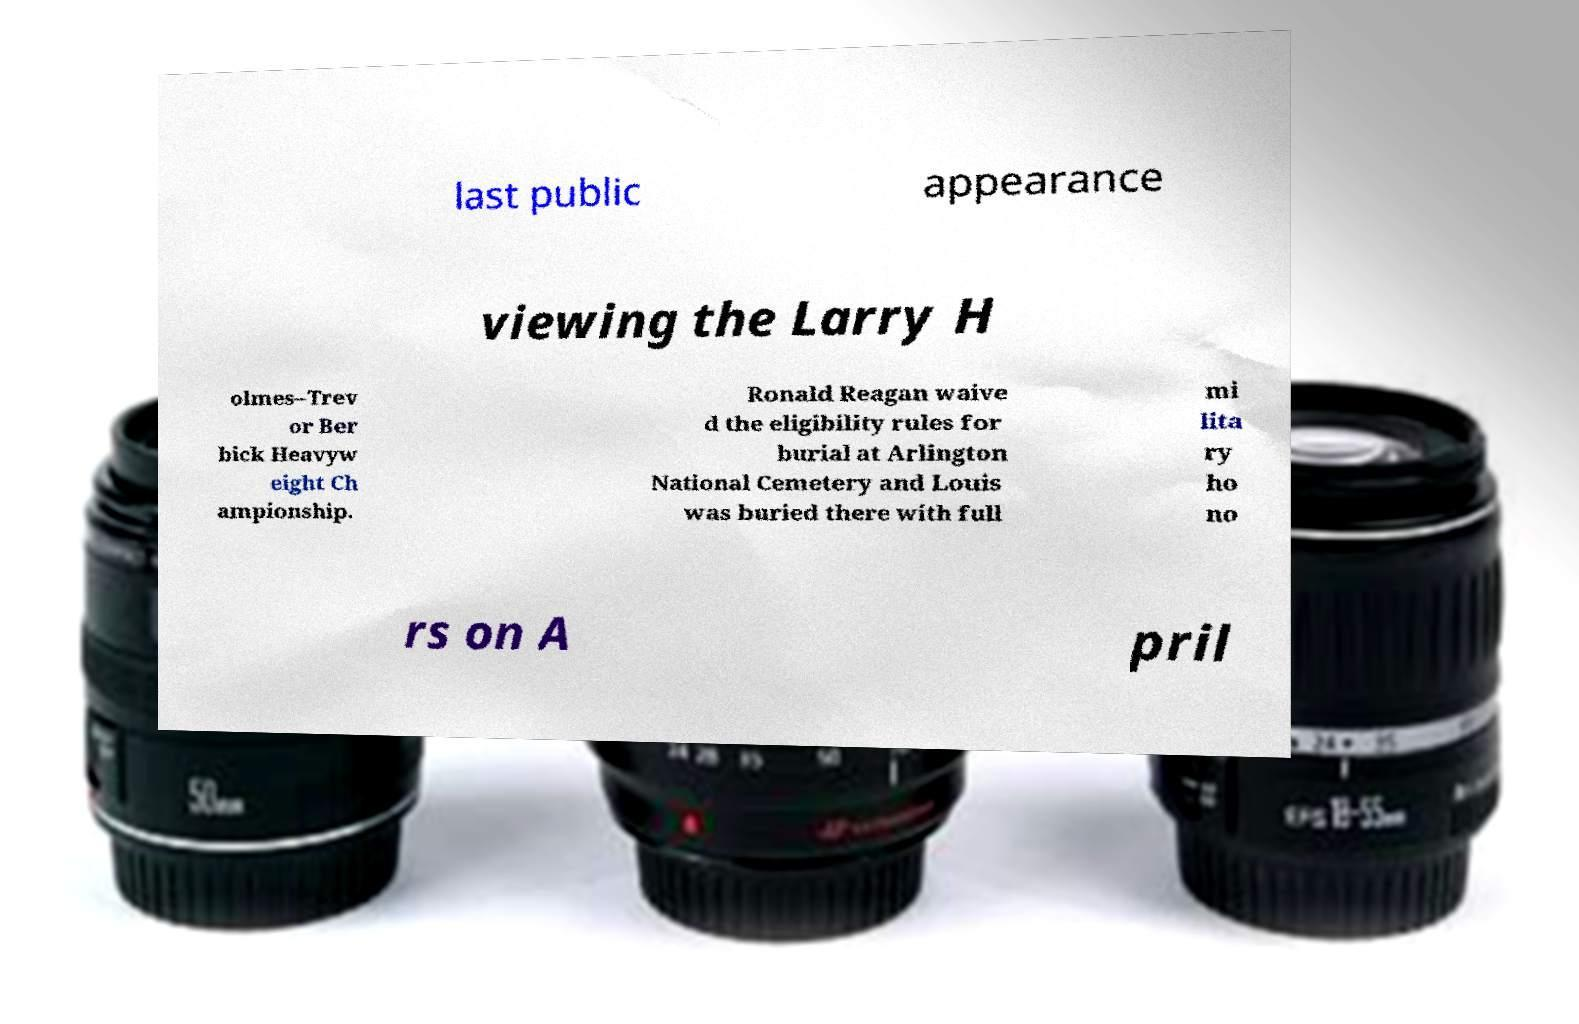Could you assist in decoding the text presented in this image and type it out clearly? last public appearance viewing the Larry H olmes–Trev or Ber bick Heavyw eight Ch ampionship. Ronald Reagan waive d the eligibility rules for burial at Arlington National Cemetery and Louis was buried there with full mi lita ry ho no rs on A pril 